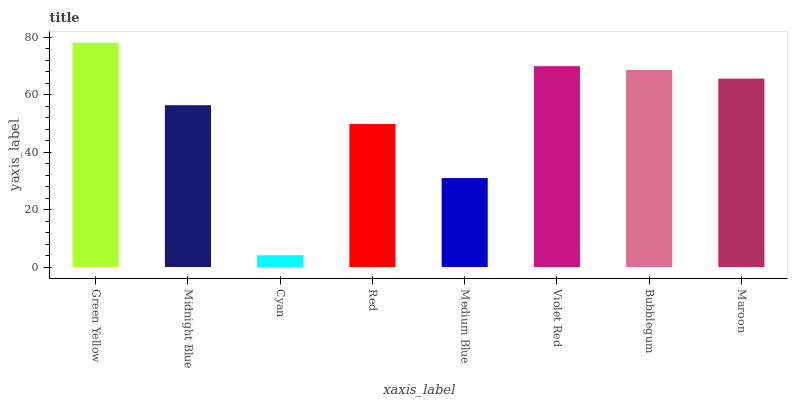Is Cyan the minimum?
Answer yes or no. Yes. Is Green Yellow the maximum?
Answer yes or no. Yes. Is Midnight Blue the minimum?
Answer yes or no. No. Is Midnight Blue the maximum?
Answer yes or no. No. Is Green Yellow greater than Midnight Blue?
Answer yes or no. Yes. Is Midnight Blue less than Green Yellow?
Answer yes or no. Yes. Is Midnight Blue greater than Green Yellow?
Answer yes or no. No. Is Green Yellow less than Midnight Blue?
Answer yes or no. No. Is Maroon the high median?
Answer yes or no. Yes. Is Midnight Blue the low median?
Answer yes or no. Yes. Is Cyan the high median?
Answer yes or no. No. Is Green Yellow the low median?
Answer yes or no. No. 